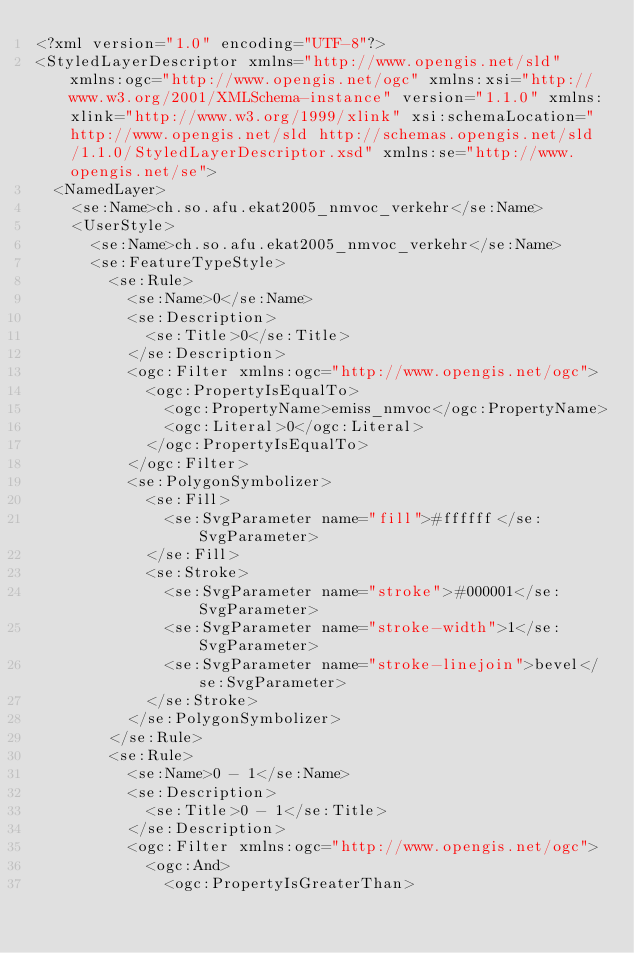Convert code to text. <code><loc_0><loc_0><loc_500><loc_500><_Scheme_><?xml version="1.0" encoding="UTF-8"?>
<StyledLayerDescriptor xmlns="http://www.opengis.net/sld" xmlns:ogc="http://www.opengis.net/ogc" xmlns:xsi="http://www.w3.org/2001/XMLSchema-instance" version="1.1.0" xmlns:xlink="http://www.w3.org/1999/xlink" xsi:schemaLocation="http://www.opengis.net/sld http://schemas.opengis.net/sld/1.1.0/StyledLayerDescriptor.xsd" xmlns:se="http://www.opengis.net/se">
  <NamedLayer>
    <se:Name>ch.so.afu.ekat2005_nmvoc_verkehr</se:Name>
    <UserStyle>
      <se:Name>ch.so.afu.ekat2005_nmvoc_verkehr</se:Name>
      <se:FeatureTypeStyle>
        <se:Rule>
          <se:Name>0</se:Name>
          <se:Description>
            <se:Title>0</se:Title>
          </se:Description>
          <ogc:Filter xmlns:ogc="http://www.opengis.net/ogc">
            <ogc:PropertyIsEqualTo>
              <ogc:PropertyName>emiss_nmvoc</ogc:PropertyName>
              <ogc:Literal>0</ogc:Literal>
            </ogc:PropertyIsEqualTo>
          </ogc:Filter>
          <se:PolygonSymbolizer>
            <se:Fill>
              <se:SvgParameter name="fill">#ffffff</se:SvgParameter>
            </se:Fill>
            <se:Stroke>
              <se:SvgParameter name="stroke">#000001</se:SvgParameter>
              <se:SvgParameter name="stroke-width">1</se:SvgParameter>
              <se:SvgParameter name="stroke-linejoin">bevel</se:SvgParameter>
            </se:Stroke>
          </se:PolygonSymbolizer>
        </se:Rule>
        <se:Rule>
          <se:Name>0 - 1</se:Name>
          <se:Description>
            <se:Title>0 - 1</se:Title>
          </se:Description>
          <ogc:Filter xmlns:ogc="http://www.opengis.net/ogc">
            <ogc:And>
              <ogc:PropertyIsGreaterThan></code> 